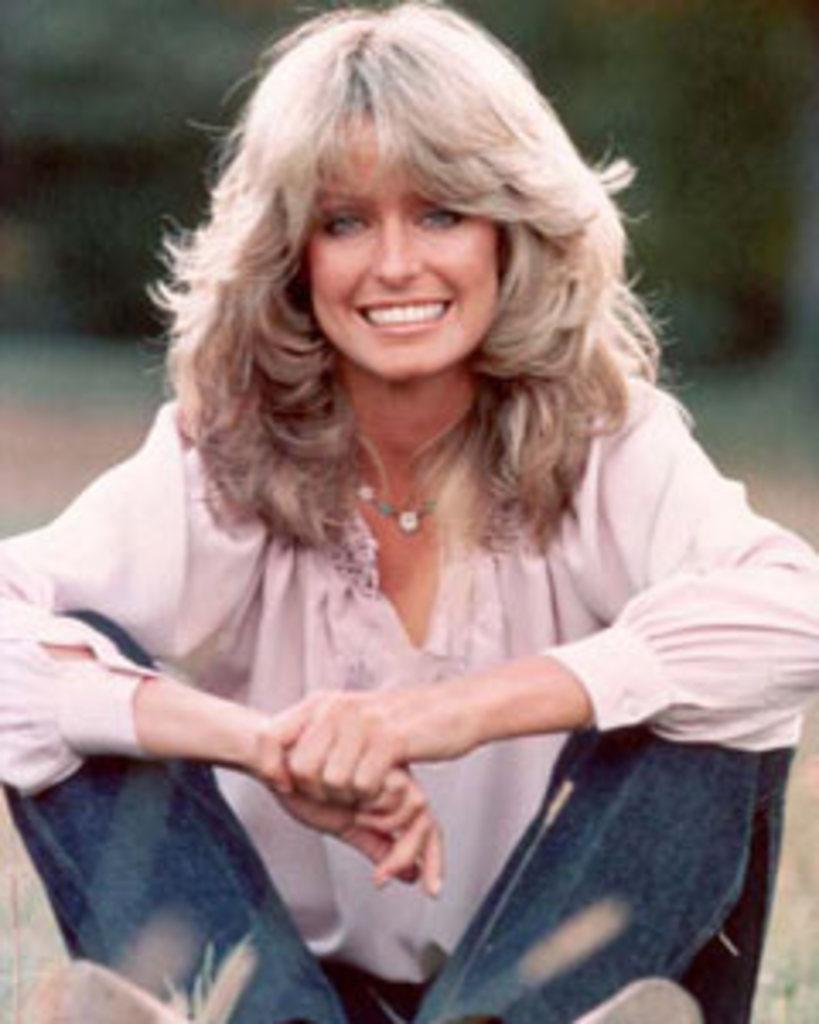Who is present in the image? There is a woman in the image. What is the woman doing in the image? The woman is sitting on the ground. What is the ground covered with? The ground is covered with grass. What is the woman's expression in the image? The woman is smiling. What type of structure can be seen in the background of the image? There is no structure visible in the background of the image; it only shows the woman sitting on grass. 